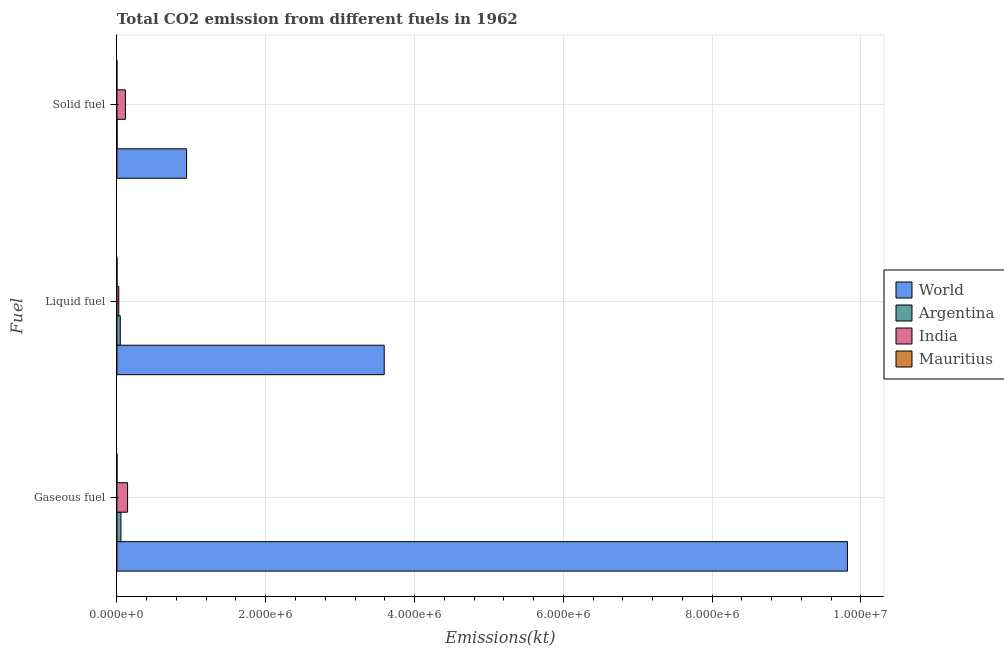How many different coloured bars are there?
Provide a succinct answer. 4. How many bars are there on the 2nd tick from the top?
Your response must be concise. 4. What is the label of the 2nd group of bars from the top?
Offer a terse response. Liquid fuel. What is the amount of co2 emissions from gaseous fuel in Mauritius?
Give a very brief answer. 253.02. Across all countries, what is the maximum amount of co2 emissions from solid fuel?
Keep it short and to the point. 9.36e+05. Across all countries, what is the minimum amount of co2 emissions from gaseous fuel?
Your response must be concise. 253.02. In which country was the amount of co2 emissions from gaseous fuel minimum?
Offer a terse response. Mauritius. What is the total amount of co2 emissions from liquid fuel in the graph?
Your answer should be very brief. 3.66e+06. What is the difference between the amount of co2 emissions from solid fuel in Mauritius and that in Argentina?
Offer a very short reply. -2002.18. What is the difference between the amount of co2 emissions from solid fuel in Mauritius and the amount of co2 emissions from liquid fuel in World?
Give a very brief answer. -3.59e+06. What is the average amount of co2 emissions from solid fuel per country?
Offer a very short reply. 2.63e+05. What is the difference between the amount of co2 emissions from liquid fuel and amount of co2 emissions from solid fuel in India?
Keep it short and to the point. -8.93e+04. In how many countries, is the amount of co2 emissions from liquid fuel greater than 9200000 kt?
Your answer should be compact. 0. What is the ratio of the amount of co2 emissions from liquid fuel in Mauritius to that in India?
Your response must be concise. 0.01. What is the difference between the highest and the second highest amount of co2 emissions from liquid fuel?
Ensure brevity in your answer.  3.55e+06. What is the difference between the highest and the lowest amount of co2 emissions from liquid fuel?
Offer a very short reply. 3.59e+06. In how many countries, is the amount of co2 emissions from solid fuel greater than the average amount of co2 emissions from solid fuel taken over all countries?
Your response must be concise. 1. How many bars are there?
Keep it short and to the point. 12. How many countries are there in the graph?
Offer a terse response. 4. Are the values on the major ticks of X-axis written in scientific E-notation?
Ensure brevity in your answer.  Yes. Does the graph contain any zero values?
Your answer should be very brief. No. How are the legend labels stacked?
Keep it short and to the point. Vertical. What is the title of the graph?
Your answer should be very brief. Total CO2 emission from different fuels in 1962. Does "Heavily indebted poor countries" appear as one of the legend labels in the graph?
Keep it short and to the point. No. What is the label or title of the X-axis?
Your answer should be compact. Emissions(kt). What is the label or title of the Y-axis?
Offer a terse response. Fuel. What is the Emissions(kt) in World in Gaseous fuel?
Offer a terse response. 9.82e+06. What is the Emissions(kt) of Argentina in Gaseous fuel?
Keep it short and to the point. 5.37e+04. What is the Emissions(kt) in India in Gaseous fuel?
Your answer should be compact. 1.43e+05. What is the Emissions(kt) in Mauritius in Gaseous fuel?
Provide a short and direct response. 253.02. What is the Emissions(kt) of World in Liquid fuel?
Offer a very short reply. 3.59e+06. What is the Emissions(kt) in Argentina in Liquid fuel?
Provide a succinct answer. 4.51e+04. What is the Emissions(kt) in India in Liquid fuel?
Offer a terse response. 2.49e+04. What is the Emissions(kt) in Mauritius in Liquid fuel?
Offer a terse response. 245.69. What is the Emissions(kt) in World in Solid fuel?
Your response must be concise. 9.36e+05. What is the Emissions(kt) in Argentina in Solid fuel?
Ensure brevity in your answer.  2009.52. What is the Emissions(kt) in India in Solid fuel?
Offer a terse response. 1.14e+05. What is the Emissions(kt) of Mauritius in Solid fuel?
Offer a very short reply. 7.33. Across all Fuel, what is the maximum Emissions(kt) in World?
Your answer should be very brief. 9.82e+06. Across all Fuel, what is the maximum Emissions(kt) in Argentina?
Make the answer very short. 5.37e+04. Across all Fuel, what is the maximum Emissions(kt) in India?
Keep it short and to the point. 1.43e+05. Across all Fuel, what is the maximum Emissions(kt) in Mauritius?
Make the answer very short. 253.02. Across all Fuel, what is the minimum Emissions(kt) in World?
Provide a short and direct response. 9.36e+05. Across all Fuel, what is the minimum Emissions(kt) of Argentina?
Offer a terse response. 2009.52. Across all Fuel, what is the minimum Emissions(kt) of India?
Offer a very short reply. 2.49e+04. Across all Fuel, what is the minimum Emissions(kt) in Mauritius?
Provide a short and direct response. 7.33. What is the total Emissions(kt) of World in the graph?
Ensure brevity in your answer.  1.43e+07. What is the total Emissions(kt) of Argentina in the graph?
Offer a terse response. 1.01e+05. What is the total Emissions(kt) in India in the graph?
Provide a succinct answer. 2.83e+05. What is the total Emissions(kt) in Mauritius in the graph?
Give a very brief answer. 506.05. What is the difference between the Emissions(kt) of World in Gaseous fuel and that in Liquid fuel?
Give a very brief answer. 6.23e+06. What is the difference between the Emissions(kt) of Argentina in Gaseous fuel and that in Liquid fuel?
Provide a short and direct response. 8580.78. What is the difference between the Emissions(kt) in India in Gaseous fuel and that in Liquid fuel?
Your answer should be compact. 1.19e+05. What is the difference between the Emissions(kt) in Mauritius in Gaseous fuel and that in Liquid fuel?
Make the answer very short. 7.33. What is the difference between the Emissions(kt) of World in Gaseous fuel and that in Solid fuel?
Give a very brief answer. 8.88e+06. What is the difference between the Emissions(kt) in Argentina in Gaseous fuel and that in Solid fuel?
Your answer should be very brief. 5.17e+04. What is the difference between the Emissions(kt) of India in Gaseous fuel and that in Solid fuel?
Give a very brief answer. 2.92e+04. What is the difference between the Emissions(kt) of Mauritius in Gaseous fuel and that in Solid fuel?
Keep it short and to the point. 245.69. What is the difference between the Emissions(kt) of World in Liquid fuel and that in Solid fuel?
Offer a terse response. 2.66e+06. What is the difference between the Emissions(kt) of Argentina in Liquid fuel and that in Solid fuel?
Provide a succinct answer. 4.31e+04. What is the difference between the Emissions(kt) in India in Liquid fuel and that in Solid fuel?
Offer a very short reply. -8.93e+04. What is the difference between the Emissions(kt) in Mauritius in Liquid fuel and that in Solid fuel?
Your answer should be very brief. 238.35. What is the difference between the Emissions(kt) in World in Gaseous fuel and the Emissions(kt) in Argentina in Liquid fuel?
Provide a succinct answer. 9.77e+06. What is the difference between the Emissions(kt) of World in Gaseous fuel and the Emissions(kt) of India in Liquid fuel?
Ensure brevity in your answer.  9.79e+06. What is the difference between the Emissions(kt) in World in Gaseous fuel and the Emissions(kt) in Mauritius in Liquid fuel?
Offer a very short reply. 9.82e+06. What is the difference between the Emissions(kt) in Argentina in Gaseous fuel and the Emissions(kt) in India in Liquid fuel?
Offer a terse response. 2.88e+04. What is the difference between the Emissions(kt) in Argentina in Gaseous fuel and the Emissions(kt) in Mauritius in Liquid fuel?
Offer a terse response. 5.35e+04. What is the difference between the Emissions(kt) of India in Gaseous fuel and the Emissions(kt) of Mauritius in Liquid fuel?
Offer a terse response. 1.43e+05. What is the difference between the Emissions(kt) in World in Gaseous fuel and the Emissions(kt) in Argentina in Solid fuel?
Offer a very short reply. 9.82e+06. What is the difference between the Emissions(kt) in World in Gaseous fuel and the Emissions(kt) in India in Solid fuel?
Keep it short and to the point. 9.70e+06. What is the difference between the Emissions(kt) in World in Gaseous fuel and the Emissions(kt) in Mauritius in Solid fuel?
Offer a terse response. 9.82e+06. What is the difference between the Emissions(kt) of Argentina in Gaseous fuel and the Emissions(kt) of India in Solid fuel?
Offer a terse response. -6.05e+04. What is the difference between the Emissions(kt) of Argentina in Gaseous fuel and the Emissions(kt) of Mauritius in Solid fuel?
Your answer should be very brief. 5.37e+04. What is the difference between the Emissions(kt) of India in Gaseous fuel and the Emissions(kt) of Mauritius in Solid fuel?
Ensure brevity in your answer.  1.43e+05. What is the difference between the Emissions(kt) of World in Liquid fuel and the Emissions(kt) of Argentina in Solid fuel?
Offer a very short reply. 3.59e+06. What is the difference between the Emissions(kt) of World in Liquid fuel and the Emissions(kt) of India in Solid fuel?
Your answer should be compact. 3.48e+06. What is the difference between the Emissions(kt) in World in Liquid fuel and the Emissions(kt) in Mauritius in Solid fuel?
Your answer should be compact. 3.59e+06. What is the difference between the Emissions(kt) of Argentina in Liquid fuel and the Emissions(kt) of India in Solid fuel?
Provide a succinct answer. -6.91e+04. What is the difference between the Emissions(kt) in Argentina in Liquid fuel and the Emissions(kt) in Mauritius in Solid fuel?
Keep it short and to the point. 4.51e+04. What is the difference between the Emissions(kt) in India in Liquid fuel and the Emissions(kt) in Mauritius in Solid fuel?
Provide a succinct answer. 2.49e+04. What is the average Emissions(kt) in World per Fuel?
Provide a short and direct response. 4.78e+06. What is the average Emissions(kt) of Argentina per Fuel?
Your answer should be very brief. 3.36e+04. What is the average Emissions(kt) of India per Fuel?
Give a very brief answer. 9.42e+04. What is the average Emissions(kt) of Mauritius per Fuel?
Your answer should be compact. 168.68. What is the difference between the Emissions(kt) in World and Emissions(kt) in Argentina in Gaseous fuel?
Offer a very short reply. 9.77e+06. What is the difference between the Emissions(kt) of World and Emissions(kt) of India in Gaseous fuel?
Give a very brief answer. 9.68e+06. What is the difference between the Emissions(kt) in World and Emissions(kt) in Mauritius in Gaseous fuel?
Offer a terse response. 9.82e+06. What is the difference between the Emissions(kt) in Argentina and Emissions(kt) in India in Gaseous fuel?
Offer a very short reply. -8.98e+04. What is the difference between the Emissions(kt) of Argentina and Emissions(kt) of Mauritius in Gaseous fuel?
Ensure brevity in your answer.  5.34e+04. What is the difference between the Emissions(kt) in India and Emissions(kt) in Mauritius in Gaseous fuel?
Your answer should be very brief. 1.43e+05. What is the difference between the Emissions(kt) of World and Emissions(kt) of Argentina in Liquid fuel?
Your response must be concise. 3.55e+06. What is the difference between the Emissions(kt) of World and Emissions(kt) of India in Liquid fuel?
Offer a very short reply. 3.57e+06. What is the difference between the Emissions(kt) of World and Emissions(kt) of Mauritius in Liquid fuel?
Your answer should be compact. 3.59e+06. What is the difference between the Emissions(kt) in Argentina and Emissions(kt) in India in Liquid fuel?
Keep it short and to the point. 2.02e+04. What is the difference between the Emissions(kt) of Argentina and Emissions(kt) of Mauritius in Liquid fuel?
Offer a very short reply. 4.49e+04. What is the difference between the Emissions(kt) of India and Emissions(kt) of Mauritius in Liquid fuel?
Provide a short and direct response. 2.47e+04. What is the difference between the Emissions(kt) of World and Emissions(kt) of Argentina in Solid fuel?
Make the answer very short. 9.34e+05. What is the difference between the Emissions(kt) of World and Emissions(kt) of India in Solid fuel?
Provide a short and direct response. 8.22e+05. What is the difference between the Emissions(kt) in World and Emissions(kt) in Mauritius in Solid fuel?
Your response must be concise. 9.36e+05. What is the difference between the Emissions(kt) in Argentina and Emissions(kt) in India in Solid fuel?
Your response must be concise. -1.12e+05. What is the difference between the Emissions(kt) of Argentina and Emissions(kt) of Mauritius in Solid fuel?
Provide a short and direct response. 2002.18. What is the difference between the Emissions(kt) in India and Emissions(kt) in Mauritius in Solid fuel?
Keep it short and to the point. 1.14e+05. What is the ratio of the Emissions(kt) of World in Gaseous fuel to that in Liquid fuel?
Offer a very short reply. 2.73. What is the ratio of the Emissions(kt) of Argentina in Gaseous fuel to that in Liquid fuel?
Your answer should be compact. 1.19. What is the ratio of the Emissions(kt) in India in Gaseous fuel to that in Liquid fuel?
Your answer should be compact. 5.76. What is the ratio of the Emissions(kt) in Mauritius in Gaseous fuel to that in Liquid fuel?
Provide a succinct answer. 1.03. What is the ratio of the Emissions(kt) in World in Gaseous fuel to that in Solid fuel?
Provide a succinct answer. 10.49. What is the ratio of the Emissions(kt) in Argentina in Gaseous fuel to that in Solid fuel?
Offer a terse response. 26.72. What is the ratio of the Emissions(kt) of India in Gaseous fuel to that in Solid fuel?
Provide a short and direct response. 1.26. What is the ratio of the Emissions(kt) in Mauritius in Gaseous fuel to that in Solid fuel?
Your response must be concise. 34.5. What is the ratio of the Emissions(kt) of World in Liquid fuel to that in Solid fuel?
Give a very brief answer. 3.84. What is the ratio of the Emissions(kt) in Argentina in Liquid fuel to that in Solid fuel?
Your answer should be very brief. 22.45. What is the ratio of the Emissions(kt) in India in Liquid fuel to that in Solid fuel?
Your response must be concise. 0.22. What is the ratio of the Emissions(kt) of Mauritius in Liquid fuel to that in Solid fuel?
Make the answer very short. 33.5. What is the difference between the highest and the second highest Emissions(kt) of World?
Your answer should be very brief. 6.23e+06. What is the difference between the highest and the second highest Emissions(kt) of Argentina?
Your answer should be compact. 8580.78. What is the difference between the highest and the second highest Emissions(kt) in India?
Your answer should be compact. 2.92e+04. What is the difference between the highest and the second highest Emissions(kt) of Mauritius?
Your answer should be very brief. 7.33. What is the difference between the highest and the lowest Emissions(kt) of World?
Offer a terse response. 8.88e+06. What is the difference between the highest and the lowest Emissions(kt) in Argentina?
Give a very brief answer. 5.17e+04. What is the difference between the highest and the lowest Emissions(kt) of India?
Offer a terse response. 1.19e+05. What is the difference between the highest and the lowest Emissions(kt) in Mauritius?
Ensure brevity in your answer.  245.69. 